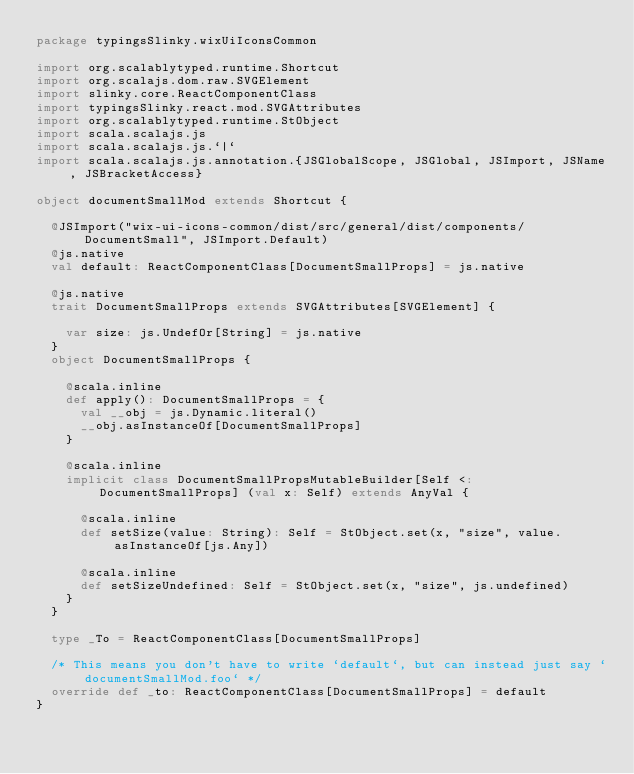<code> <loc_0><loc_0><loc_500><loc_500><_Scala_>package typingsSlinky.wixUiIconsCommon

import org.scalablytyped.runtime.Shortcut
import org.scalajs.dom.raw.SVGElement
import slinky.core.ReactComponentClass
import typingsSlinky.react.mod.SVGAttributes
import org.scalablytyped.runtime.StObject
import scala.scalajs.js
import scala.scalajs.js.`|`
import scala.scalajs.js.annotation.{JSGlobalScope, JSGlobal, JSImport, JSName, JSBracketAccess}

object documentSmallMod extends Shortcut {
  
  @JSImport("wix-ui-icons-common/dist/src/general/dist/components/DocumentSmall", JSImport.Default)
  @js.native
  val default: ReactComponentClass[DocumentSmallProps] = js.native
  
  @js.native
  trait DocumentSmallProps extends SVGAttributes[SVGElement] {
    
    var size: js.UndefOr[String] = js.native
  }
  object DocumentSmallProps {
    
    @scala.inline
    def apply(): DocumentSmallProps = {
      val __obj = js.Dynamic.literal()
      __obj.asInstanceOf[DocumentSmallProps]
    }
    
    @scala.inline
    implicit class DocumentSmallPropsMutableBuilder[Self <: DocumentSmallProps] (val x: Self) extends AnyVal {
      
      @scala.inline
      def setSize(value: String): Self = StObject.set(x, "size", value.asInstanceOf[js.Any])
      
      @scala.inline
      def setSizeUndefined: Self = StObject.set(x, "size", js.undefined)
    }
  }
  
  type _To = ReactComponentClass[DocumentSmallProps]
  
  /* This means you don't have to write `default`, but can instead just say `documentSmallMod.foo` */
  override def _to: ReactComponentClass[DocumentSmallProps] = default
}
</code> 